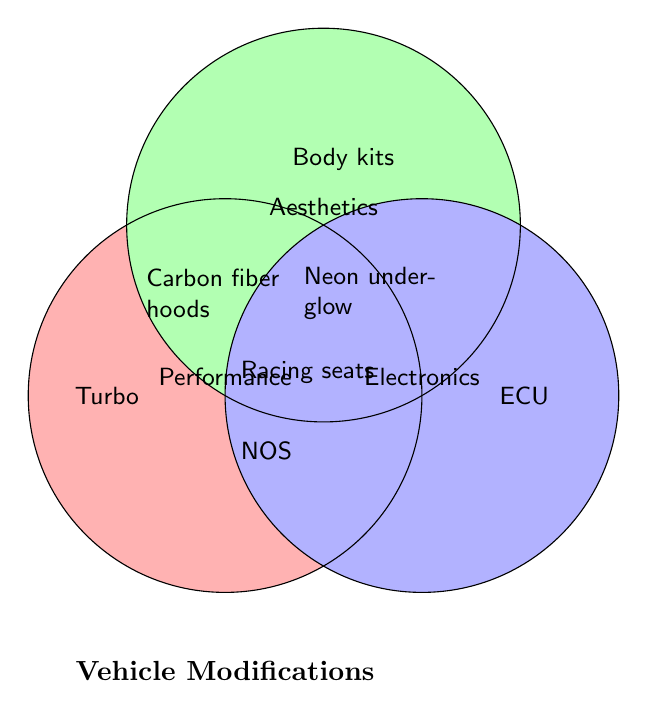What is the title of the figure? The title typically appears at the bottom or top of a figure and is surrounded by the diagram elements and labels.
Answer: Vehicle Modifications Which categories overlap for Carbon fiber hoods? Carbon fiber hoods are located in the intersection area between different circles; specifically, they lie between Performance and Aesthetics.
Answer: Performance and Aesthetics What color represents the Electronics category? The color of each category is defined by the fill color of the corresponding circle. The Electronics category is represented by blue.
Answer: Blue How many items fall exclusively under the Performance category? To determine the exclusive items, look at those within the Performance circle that do not overlap with the other circles. These items are: Turbochargers, Cold air intakes, and High-flow exhausts.
Answer: 3 What modification category do Racing seats fall under? Racing seats are placed in the area where all three circles overlap, indicating they fall under Performance, Aesthetics, and Electronics.
Answer: Performance, Aesthetics, and Electronics Compare the number of exclusive items in Performance and Aesthetics categories. Which has more? Count the exclusive items in each circle separately and then compare. Performance has Turbochargers, Cold air intakes, and High-flow exhausts (3 items). Aesthetics has Body kits, Custom paint jobs, and Alloy wheels (3 items).
Answer: Equal Which category or categories does NOS belong to? NOS (Nitrous oxide systems) is placed in the overlapping area of Performance and Electronics.
Answer: Performance and Electronics What is placed in the intersection of all three categories? The item placed in the overlapping region of all three circles, representing all categories, is Racing seats.
Answer: Racing seats Which modification is shared by Aesthetics and Electronics, excluding any other category? Look at the items in the overlapping section of Aesthetics and Electronics only. It is Neon underglow.
Answer: Neon underglow What feature is exclusively in the Electronics category? The exclusive item in the Electronics circle does not overlap with any other circle. This item is Engine management systems, Touchscreen infotainment, and LED lighting.
Answer: Engine management systems, Touchscreen infotainment, and LED lighting 